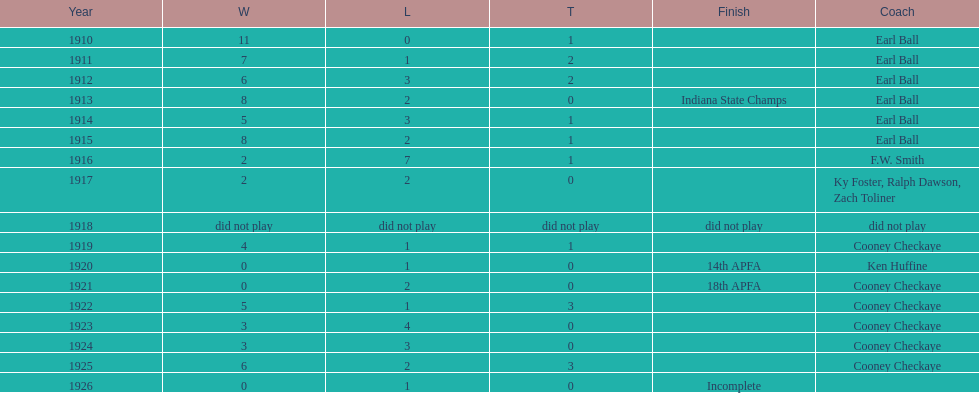In what year were the muncie flyers able to maintain a perfect record? 1910. 